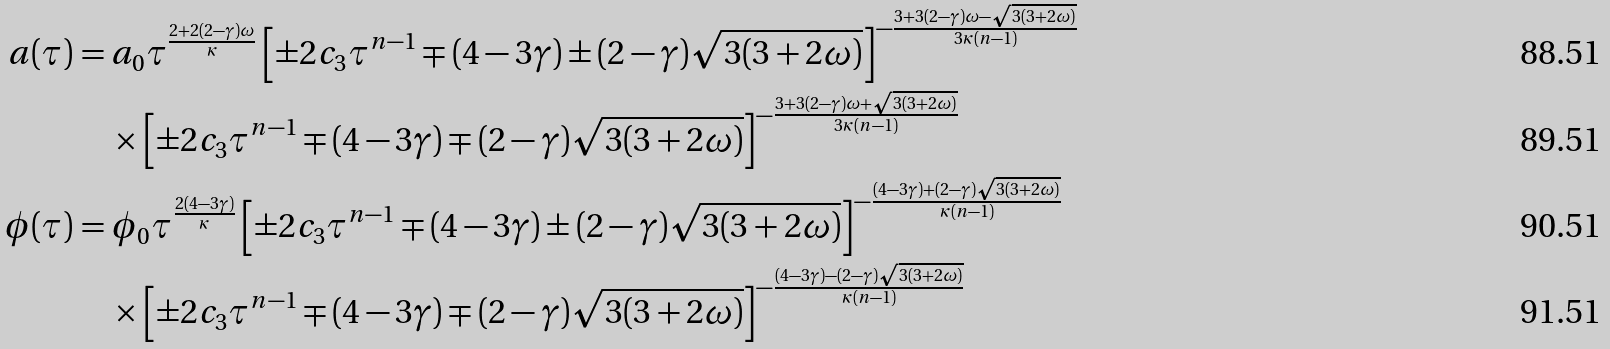<formula> <loc_0><loc_0><loc_500><loc_500>a ( \tau ) & = a _ { 0 } \tau ^ { \frac { 2 + 2 ( 2 - \gamma ) \omega } { \kappa } } \left [ \pm 2 c _ { 3 } \tau ^ { n - 1 } \mp ( 4 - 3 \gamma ) \pm ( 2 - \gamma ) \sqrt { 3 ( 3 + 2 \omega ) } \right ] ^ { - \frac { 3 + 3 ( 2 - \gamma ) \omega - \sqrt { 3 ( 3 + 2 \omega ) } } { 3 \kappa ( n - 1 ) } } \\ & \quad \times \left [ \pm 2 c _ { 3 } \tau ^ { n - 1 } \mp ( 4 - 3 \gamma ) \mp ( 2 - \gamma ) \sqrt { 3 ( 3 + 2 \omega ) } \right ] ^ { - \frac { 3 + 3 ( 2 - \gamma ) \omega + \sqrt { 3 ( 3 + 2 \omega ) } } { 3 \kappa ( n - 1 ) } } \\ \phi ( \tau ) & = \phi _ { 0 } \tau ^ { \frac { 2 ( 4 - 3 \gamma ) } { \kappa } } \left [ \pm 2 c _ { 3 } \tau ^ { n - 1 } \mp ( 4 - 3 \gamma ) \pm ( 2 - \gamma ) \sqrt { 3 ( 3 + 2 \omega ) } \right ] ^ { - \frac { ( 4 - 3 \gamma ) + ( 2 - \gamma ) \sqrt { 3 ( 3 + 2 \omega ) } } { \kappa ( n - 1 ) } } \\ & \quad \times \left [ \pm 2 c _ { 3 } \tau ^ { n - 1 } \mp ( 4 - 3 \gamma ) \mp ( 2 - \gamma ) \sqrt { 3 ( 3 + 2 \omega ) } \right ] ^ { - \frac { ( 4 - 3 \gamma ) - ( 2 - \gamma ) \sqrt { 3 ( 3 + 2 \omega ) } } { \kappa ( n - 1 ) } }</formula> 